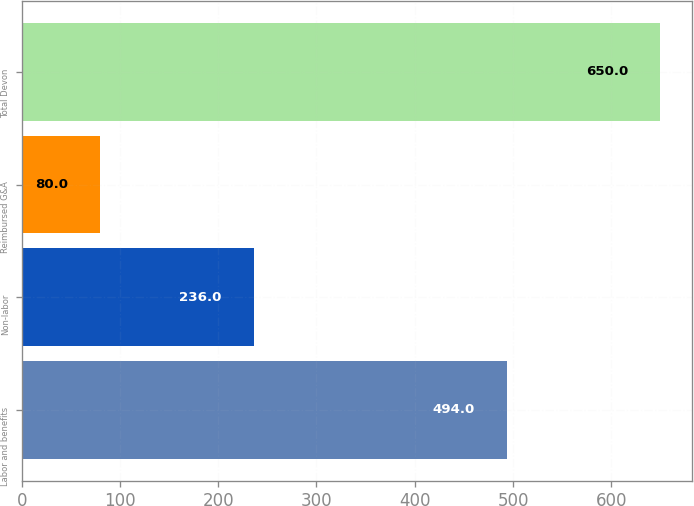Convert chart to OTSL. <chart><loc_0><loc_0><loc_500><loc_500><bar_chart><fcel>Labor and benefits<fcel>Non-labor<fcel>Reimbursed G&A<fcel>Total Devon<nl><fcel>494<fcel>236<fcel>80<fcel>650<nl></chart> 